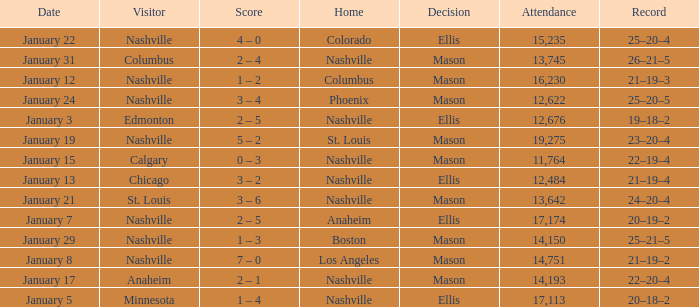On January 29, who had the decision of Mason? Nashville. 